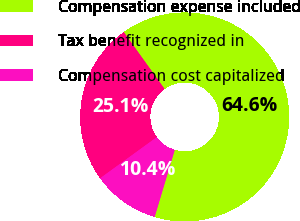Convert chart to OTSL. <chart><loc_0><loc_0><loc_500><loc_500><pie_chart><fcel>Compensation expense included<fcel>Tax benefit recognized in<fcel>Compensation cost capitalized<nl><fcel>64.55%<fcel>25.08%<fcel>10.37%<nl></chart> 